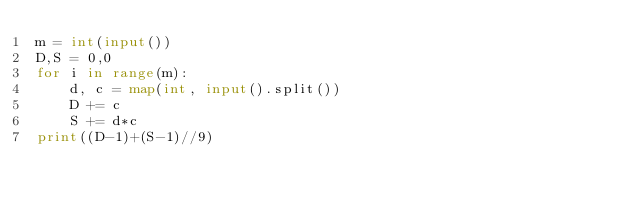<code> <loc_0><loc_0><loc_500><loc_500><_Python_>m = int(input())
D,S = 0,0
for i in range(m):
    d, c = map(int, input().split())
    D += c
    S += d*c
print((D-1)+(S-1)//9)</code> 